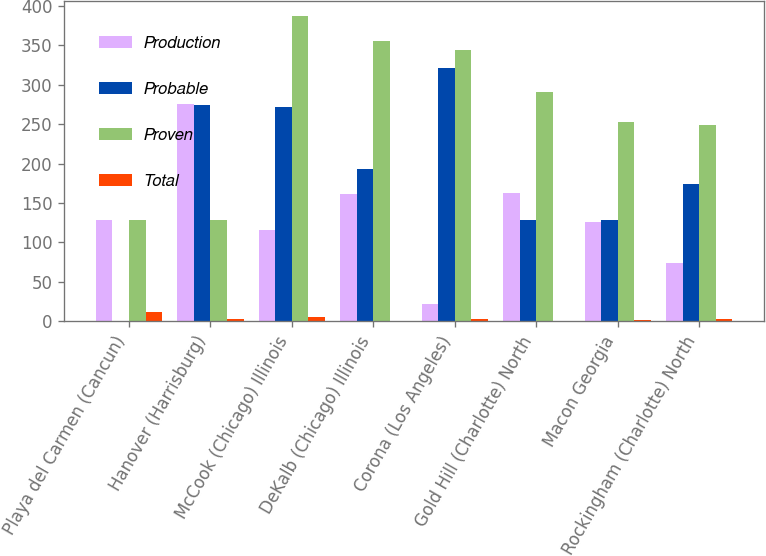<chart> <loc_0><loc_0><loc_500><loc_500><stacked_bar_chart><ecel><fcel>Playa del Carmen (Cancun)<fcel>Hanover (Harrisburg)<fcel>McCook (Chicago) Illinois<fcel>DeKalb (Chicago) Illinois<fcel>Corona (Los Angeles)<fcel>Gold Hill (Charlotte) North<fcel>Macon Georgia<fcel>Rockingham (Charlotte) North<nl><fcel>Production<fcel>128.9<fcel>275.9<fcel>116<fcel>161.9<fcel>22.5<fcel>162.3<fcel>125.3<fcel>74.3<nl><fcel>Probable<fcel>0<fcel>274.4<fcel>271.2<fcel>193.7<fcel>321.5<fcel>128.9<fcel>128<fcel>174.6<nl><fcel>Proven<fcel>128.9<fcel>128.9<fcel>387.2<fcel>355.6<fcel>344<fcel>291.2<fcel>253.3<fcel>248.9<nl><fcel>Total<fcel>12.3<fcel>2.7<fcel>5.7<fcel>0.2<fcel>2.6<fcel>0.8<fcel>1.2<fcel>2.3<nl></chart> 